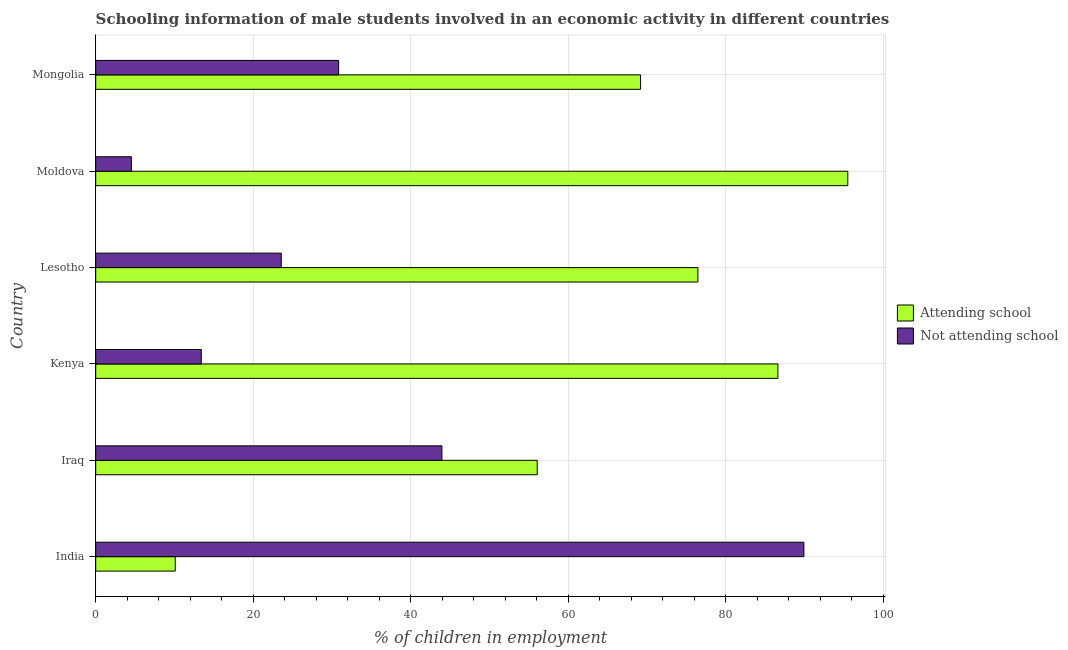How many groups of bars are there?
Your response must be concise. 6. Are the number of bars on each tick of the Y-axis equal?
Your answer should be very brief. Yes. What is the label of the 2nd group of bars from the top?
Provide a succinct answer. Moldova. Across all countries, what is the maximum percentage of employed males who are not attending school?
Provide a short and direct response. 89.9. In which country was the percentage of employed males who are attending school minimum?
Ensure brevity in your answer.  India. What is the total percentage of employed males who are not attending school in the graph?
Ensure brevity in your answer.  206.16. What is the difference between the percentage of employed males who are not attending school in Kenya and that in Moldova?
Keep it short and to the point. 8.87. What is the difference between the percentage of employed males who are not attending school in Mongolia and the percentage of employed males who are attending school in Moldova?
Ensure brevity in your answer.  -64.64. What is the average percentage of employed males who are not attending school per country?
Provide a succinct answer. 34.36. What is the difference between the percentage of employed males who are not attending school and percentage of employed males who are attending school in Iraq?
Give a very brief answer. -12.1. In how many countries, is the percentage of employed males who are not attending school greater than 72 %?
Your answer should be compact. 1. What is the ratio of the percentage of employed males who are not attending school in India to that in Mongolia?
Provide a succinct answer. 2.92. Is the percentage of employed males who are not attending school in India less than that in Mongolia?
Give a very brief answer. No. Is the difference between the percentage of employed males who are not attending school in Iraq and Mongolia greater than the difference between the percentage of employed males who are attending school in Iraq and Mongolia?
Ensure brevity in your answer.  Yes. What is the difference between the highest and the second highest percentage of employed males who are not attending school?
Provide a succinct answer. 45.95. What is the difference between the highest and the lowest percentage of employed males who are attending school?
Your answer should be very brief. 85.37. Is the sum of the percentage of employed males who are attending school in Iraq and Moldova greater than the maximum percentage of employed males who are not attending school across all countries?
Your response must be concise. Yes. What does the 1st bar from the top in Moldova represents?
Your answer should be very brief. Not attending school. What does the 2nd bar from the bottom in Kenya represents?
Ensure brevity in your answer.  Not attending school. How many countries are there in the graph?
Offer a terse response. 6. What is the difference between two consecutive major ticks on the X-axis?
Keep it short and to the point. 20. Are the values on the major ticks of X-axis written in scientific E-notation?
Make the answer very short. No. Does the graph contain grids?
Give a very brief answer. Yes. What is the title of the graph?
Keep it short and to the point. Schooling information of male students involved in an economic activity in different countries. Does "Methane emissions" appear as one of the legend labels in the graph?
Ensure brevity in your answer.  No. What is the label or title of the X-axis?
Provide a short and direct response. % of children in employment. What is the label or title of the Y-axis?
Your answer should be very brief. Country. What is the % of children in employment in Attending school in India?
Provide a short and direct response. 10.1. What is the % of children in employment in Not attending school in India?
Make the answer very short. 89.9. What is the % of children in employment in Attending school in Iraq?
Your answer should be compact. 56.05. What is the % of children in employment in Not attending school in Iraq?
Offer a very short reply. 43.95. What is the % of children in employment in Attending school in Kenya?
Your response must be concise. 86.6. What is the % of children in employment in Attending school in Lesotho?
Keep it short and to the point. 76.45. What is the % of children in employment in Not attending school in Lesotho?
Provide a short and direct response. 23.55. What is the % of children in employment in Attending school in Moldova?
Your answer should be very brief. 95.47. What is the % of children in employment of Not attending school in Moldova?
Ensure brevity in your answer.  4.53. What is the % of children in employment of Attending school in Mongolia?
Your response must be concise. 69.17. What is the % of children in employment of Not attending school in Mongolia?
Offer a terse response. 30.83. Across all countries, what is the maximum % of children in employment of Attending school?
Your answer should be very brief. 95.47. Across all countries, what is the maximum % of children in employment in Not attending school?
Your answer should be very brief. 89.9. Across all countries, what is the minimum % of children in employment in Attending school?
Give a very brief answer. 10.1. Across all countries, what is the minimum % of children in employment in Not attending school?
Provide a short and direct response. 4.53. What is the total % of children in employment in Attending school in the graph?
Make the answer very short. 393.84. What is the total % of children in employment of Not attending school in the graph?
Ensure brevity in your answer.  206.16. What is the difference between the % of children in employment in Attending school in India and that in Iraq?
Offer a very short reply. -45.95. What is the difference between the % of children in employment in Not attending school in India and that in Iraq?
Keep it short and to the point. 45.95. What is the difference between the % of children in employment of Attending school in India and that in Kenya?
Give a very brief answer. -76.5. What is the difference between the % of children in employment in Not attending school in India and that in Kenya?
Your answer should be compact. 76.5. What is the difference between the % of children in employment of Attending school in India and that in Lesotho?
Your answer should be compact. -66.35. What is the difference between the % of children in employment of Not attending school in India and that in Lesotho?
Give a very brief answer. 66.35. What is the difference between the % of children in employment of Attending school in India and that in Moldova?
Provide a short and direct response. -85.37. What is the difference between the % of children in employment in Not attending school in India and that in Moldova?
Keep it short and to the point. 85.37. What is the difference between the % of children in employment of Attending school in India and that in Mongolia?
Offer a terse response. -59.07. What is the difference between the % of children in employment of Not attending school in India and that in Mongolia?
Provide a succinct answer. 59.07. What is the difference between the % of children in employment of Attending school in Iraq and that in Kenya?
Offer a terse response. -30.55. What is the difference between the % of children in employment in Not attending school in Iraq and that in Kenya?
Ensure brevity in your answer.  30.55. What is the difference between the % of children in employment of Attending school in Iraq and that in Lesotho?
Make the answer very short. -20.39. What is the difference between the % of children in employment in Not attending school in Iraq and that in Lesotho?
Provide a short and direct response. 20.39. What is the difference between the % of children in employment of Attending school in Iraq and that in Moldova?
Your answer should be compact. -39.42. What is the difference between the % of children in employment in Not attending school in Iraq and that in Moldova?
Your answer should be very brief. 39.42. What is the difference between the % of children in employment of Attending school in Iraq and that in Mongolia?
Your answer should be very brief. -13.12. What is the difference between the % of children in employment in Not attending school in Iraq and that in Mongolia?
Provide a short and direct response. 13.12. What is the difference between the % of children in employment in Attending school in Kenya and that in Lesotho?
Your answer should be compact. 10.15. What is the difference between the % of children in employment in Not attending school in Kenya and that in Lesotho?
Your response must be concise. -10.15. What is the difference between the % of children in employment in Attending school in Kenya and that in Moldova?
Provide a succinct answer. -8.87. What is the difference between the % of children in employment in Not attending school in Kenya and that in Moldova?
Provide a succinct answer. 8.87. What is the difference between the % of children in employment in Attending school in Kenya and that in Mongolia?
Keep it short and to the point. 17.43. What is the difference between the % of children in employment in Not attending school in Kenya and that in Mongolia?
Offer a very short reply. -17.43. What is the difference between the % of children in employment of Attending school in Lesotho and that in Moldova?
Offer a very short reply. -19.03. What is the difference between the % of children in employment of Not attending school in Lesotho and that in Moldova?
Provide a short and direct response. 19.03. What is the difference between the % of children in employment of Attending school in Lesotho and that in Mongolia?
Offer a terse response. 7.28. What is the difference between the % of children in employment of Not attending school in Lesotho and that in Mongolia?
Provide a short and direct response. -7.28. What is the difference between the % of children in employment in Attending school in Moldova and that in Mongolia?
Your answer should be compact. 26.31. What is the difference between the % of children in employment of Not attending school in Moldova and that in Mongolia?
Provide a short and direct response. -26.31. What is the difference between the % of children in employment in Attending school in India and the % of children in employment in Not attending school in Iraq?
Ensure brevity in your answer.  -33.85. What is the difference between the % of children in employment in Attending school in India and the % of children in employment in Not attending school in Lesotho?
Your answer should be compact. -13.45. What is the difference between the % of children in employment in Attending school in India and the % of children in employment in Not attending school in Moldova?
Your answer should be compact. 5.57. What is the difference between the % of children in employment of Attending school in India and the % of children in employment of Not attending school in Mongolia?
Your answer should be compact. -20.73. What is the difference between the % of children in employment of Attending school in Iraq and the % of children in employment of Not attending school in Kenya?
Ensure brevity in your answer.  42.65. What is the difference between the % of children in employment in Attending school in Iraq and the % of children in employment in Not attending school in Lesotho?
Your response must be concise. 32.5. What is the difference between the % of children in employment of Attending school in Iraq and the % of children in employment of Not attending school in Moldova?
Your response must be concise. 51.52. What is the difference between the % of children in employment in Attending school in Iraq and the % of children in employment in Not attending school in Mongolia?
Provide a succinct answer. 25.22. What is the difference between the % of children in employment in Attending school in Kenya and the % of children in employment in Not attending school in Lesotho?
Ensure brevity in your answer.  63.05. What is the difference between the % of children in employment in Attending school in Kenya and the % of children in employment in Not attending school in Moldova?
Your answer should be very brief. 82.07. What is the difference between the % of children in employment of Attending school in Kenya and the % of children in employment of Not attending school in Mongolia?
Make the answer very short. 55.77. What is the difference between the % of children in employment in Attending school in Lesotho and the % of children in employment in Not attending school in Moldova?
Keep it short and to the point. 71.92. What is the difference between the % of children in employment in Attending school in Lesotho and the % of children in employment in Not attending school in Mongolia?
Offer a terse response. 45.61. What is the difference between the % of children in employment of Attending school in Moldova and the % of children in employment of Not attending school in Mongolia?
Your answer should be very brief. 64.64. What is the average % of children in employment in Attending school per country?
Provide a short and direct response. 65.64. What is the average % of children in employment in Not attending school per country?
Keep it short and to the point. 34.36. What is the difference between the % of children in employment of Attending school and % of children in employment of Not attending school in India?
Give a very brief answer. -79.8. What is the difference between the % of children in employment in Attending school and % of children in employment in Not attending school in Iraq?
Offer a terse response. 12.1. What is the difference between the % of children in employment of Attending school and % of children in employment of Not attending school in Kenya?
Your answer should be very brief. 73.2. What is the difference between the % of children in employment in Attending school and % of children in employment in Not attending school in Lesotho?
Provide a succinct answer. 52.89. What is the difference between the % of children in employment in Attending school and % of children in employment in Not attending school in Moldova?
Keep it short and to the point. 90.95. What is the difference between the % of children in employment of Attending school and % of children in employment of Not attending school in Mongolia?
Your answer should be very brief. 38.34. What is the ratio of the % of children in employment in Attending school in India to that in Iraq?
Offer a terse response. 0.18. What is the ratio of the % of children in employment in Not attending school in India to that in Iraq?
Your answer should be very brief. 2.05. What is the ratio of the % of children in employment in Attending school in India to that in Kenya?
Offer a very short reply. 0.12. What is the ratio of the % of children in employment in Not attending school in India to that in Kenya?
Keep it short and to the point. 6.71. What is the ratio of the % of children in employment in Attending school in India to that in Lesotho?
Offer a terse response. 0.13. What is the ratio of the % of children in employment in Not attending school in India to that in Lesotho?
Give a very brief answer. 3.82. What is the ratio of the % of children in employment in Attending school in India to that in Moldova?
Provide a succinct answer. 0.11. What is the ratio of the % of children in employment in Not attending school in India to that in Moldova?
Your answer should be compact. 19.86. What is the ratio of the % of children in employment of Attending school in India to that in Mongolia?
Give a very brief answer. 0.15. What is the ratio of the % of children in employment in Not attending school in India to that in Mongolia?
Give a very brief answer. 2.92. What is the ratio of the % of children in employment of Attending school in Iraq to that in Kenya?
Your answer should be very brief. 0.65. What is the ratio of the % of children in employment of Not attending school in Iraq to that in Kenya?
Provide a short and direct response. 3.28. What is the ratio of the % of children in employment in Attending school in Iraq to that in Lesotho?
Your answer should be compact. 0.73. What is the ratio of the % of children in employment in Not attending school in Iraq to that in Lesotho?
Your response must be concise. 1.87. What is the ratio of the % of children in employment of Attending school in Iraq to that in Moldova?
Ensure brevity in your answer.  0.59. What is the ratio of the % of children in employment of Not attending school in Iraq to that in Moldova?
Offer a terse response. 9.71. What is the ratio of the % of children in employment of Attending school in Iraq to that in Mongolia?
Your answer should be very brief. 0.81. What is the ratio of the % of children in employment of Not attending school in Iraq to that in Mongolia?
Make the answer very short. 1.43. What is the ratio of the % of children in employment in Attending school in Kenya to that in Lesotho?
Make the answer very short. 1.13. What is the ratio of the % of children in employment of Not attending school in Kenya to that in Lesotho?
Offer a very short reply. 0.57. What is the ratio of the % of children in employment in Attending school in Kenya to that in Moldova?
Offer a terse response. 0.91. What is the ratio of the % of children in employment in Not attending school in Kenya to that in Moldova?
Ensure brevity in your answer.  2.96. What is the ratio of the % of children in employment in Attending school in Kenya to that in Mongolia?
Your response must be concise. 1.25. What is the ratio of the % of children in employment of Not attending school in Kenya to that in Mongolia?
Offer a very short reply. 0.43. What is the ratio of the % of children in employment of Attending school in Lesotho to that in Moldova?
Your response must be concise. 0.8. What is the ratio of the % of children in employment in Not attending school in Lesotho to that in Moldova?
Your answer should be compact. 5.2. What is the ratio of the % of children in employment in Attending school in Lesotho to that in Mongolia?
Provide a short and direct response. 1.11. What is the ratio of the % of children in employment in Not attending school in Lesotho to that in Mongolia?
Your response must be concise. 0.76. What is the ratio of the % of children in employment of Attending school in Moldova to that in Mongolia?
Your answer should be compact. 1.38. What is the ratio of the % of children in employment in Not attending school in Moldova to that in Mongolia?
Ensure brevity in your answer.  0.15. What is the difference between the highest and the second highest % of children in employment in Attending school?
Offer a terse response. 8.87. What is the difference between the highest and the second highest % of children in employment of Not attending school?
Keep it short and to the point. 45.95. What is the difference between the highest and the lowest % of children in employment in Attending school?
Your response must be concise. 85.37. What is the difference between the highest and the lowest % of children in employment of Not attending school?
Keep it short and to the point. 85.37. 